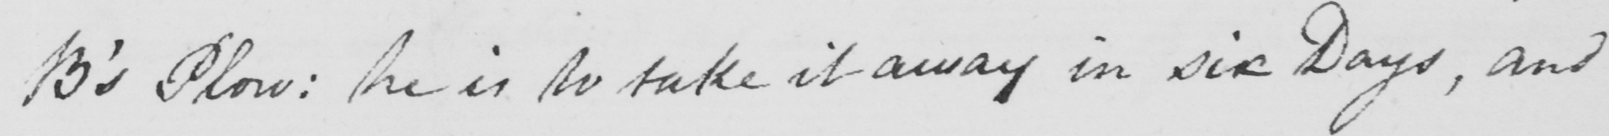Transcribe the text shown in this historical manuscript line. B ' s Plow :  he is to take it away in six Days , and 